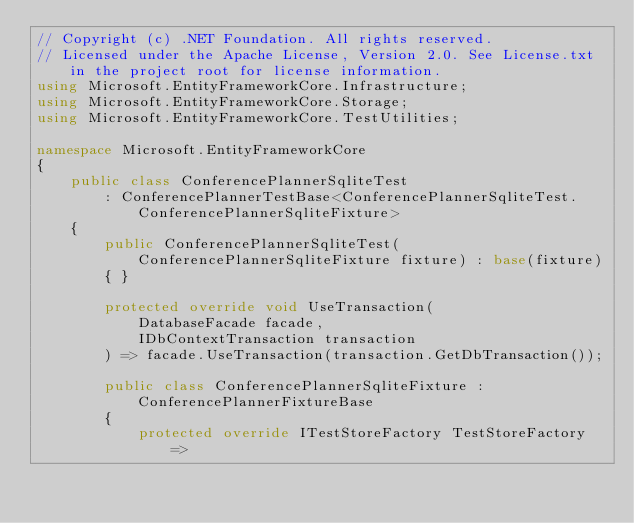Convert code to text. <code><loc_0><loc_0><loc_500><loc_500><_C#_>// Copyright (c) .NET Foundation. All rights reserved.
// Licensed under the Apache License, Version 2.0. See License.txt in the project root for license information.
using Microsoft.EntityFrameworkCore.Infrastructure;
using Microsoft.EntityFrameworkCore.Storage;
using Microsoft.EntityFrameworkCore.TestUtilities;

namespace Microsoft.EntityFrameworkCore
{
    public class ConferencePlannerSqliteTest
        : ConferencePlannerTestBase<ConferencePlannerSqliteTest.ConferencePlannerSqliteFixture>
    {
        public ConferencePlannerSqliteTest(ConferencePlannerSqliteFixture fixture) : base(fixture)
        { }

        protected override void UseTransaction(
            DatabaseFacade facade,
            IDbContextTransaction transaction
        ) => facade.UseTransaction(transaction.GetDbTransaction());

        public class ConferencePlannerSqliteFixture : ConferencePlannerFixtureBase
        {
            protected override ITestStoreFactory TestStoreFactory =></code> 